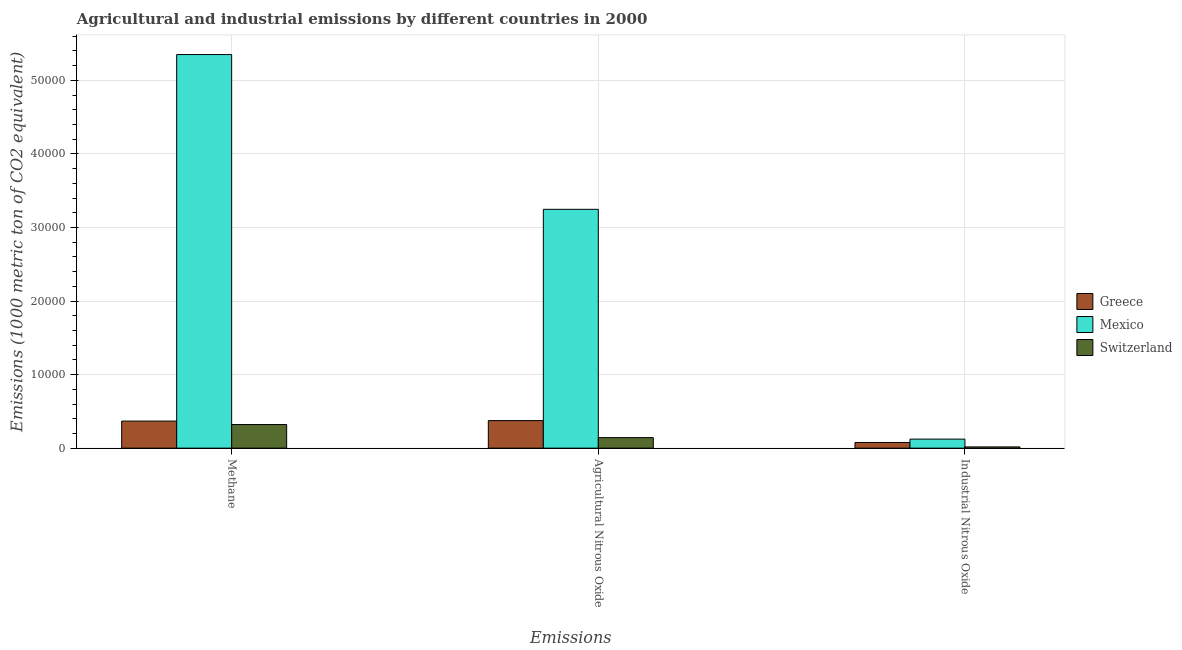How many different coloured bars are there?
Provide a short and direct response. 3. How many groups of bars are there?
Make the answer very short. 3. Are the number of bars on each tick of the X-axis equal?
Your answer should be very brief. Yes. How many bars are there on the 3rd tick from the left?
Give a very brief answer. 3. How many bars are there on the 1st tick from the right?
Offer a very short reply. 3. What is the label of the 1st group of bars from the left?
Ensure brevity in your answer.  Methane. What is the amount of agricultural nitrous oxide emissions in Mexico?
Offer a terse response. 3.25e+04. Across all countries, what is the maximum amount of methane emissions?
Provide a succinct answer. 5.35e+04. Across all countries, what is the minimum amount of agricultural nitrous oxide emissions?
Give a very brief answer. 1432.5. In which country was the amount of agricultural nitrous oxide emissions maximum?
Provide a succinct answer. Mexico. In which country was the amount of industrial nitrous oxide emissions minimum?
Provide a short and direct response. Switzerland. What is the total amount of agricultural nitrous oxide emissions in the graph?
Keep it short and to the point. 3.76e+04. What is the difference between the amount of agricultural nitrous oxide emissions in Mexico and that in Switzerland?
Your answer should be very brief. 3.10e+04. What is the difference between the amount of methane emissions in Mexico and the amount of industrial nitrous oxide emissions in Greece?
Provide a short and direct response. 5.27e+04. What is the average amount of agricultural nitrous oxide emissions per country?
Provide a short and direct response. 1.25e+04. What is the difference between the amount of industrial nitrous oxide emissions and amount of methane emissions in Greece?
Give a very brief answer. -2908.3. What is the ratio of the amount of industrial nitrous oxide emissions in Greece to that in Mexico?
Your answer should be very brief. 0.63. What is the difference between the highest and the second highest amount of methane emissions?
Offer a terse response. 4.98e+04. What is the difference between the highest and the lowest amount of agricultural nitrous oxide emissions?
Give a very brief answer. 3.10e+04. In how many countries, is the amount of agricultural nitrous oxide emissions greater than the average amount of agricultural nitrous oxide emissions taken over all countries?
Give a very brief answer. 1. What does the 3rd bar from the left in Agricultural Nitrous Oxide represents?
Provide a succinct answer. Switzerland. What does the 1st bar from the right in Agricultural Nitrous Oxide represents?
Your answer should be very brief. Switzerland. How many countries are there in the graph?
Your answer should be compact. 3. How are the legend labels stacked?
Your answer should be compact. Vertical. What is the title of the graph?
Provide a succinct answer. Agricultural and industrial emissions by different countries in 2000. What is the label or title of the X-axis?
Offer a very short reply. Emissions. What is the label or title of the Y-axis?
Give a very brief answer. Emissions (1000 metric ton of CO2 equivalent). What is the Emissions (1000 metric ton of CO2 equivalent) in Greece in Methane?
Provide a succinct answer. 3679.3. What is the Emissions (1000 metric ton of CO2 equivalent) of Mexico in Methane?
Provide a succinct answer. 5.35e+04. What is the Emissions (1000 metric ton of CO2 equivalent) of Switzerland in Methane?
Provide a succinct answer. 3210.7. What is the Emissions (1000 metric ton of CO2 equivalent) of Greece in Agricultural Nitrous Oxide?
Offer a very short reply. 3745.5. What is the Emissions (1000 metric ton of CO2 equivalent) of Mexico in Agricultural Nitrous Oxide?
Offer a terse response. 3.25e+04. What is the Emissions (1000 metric ton of CO2 equivalent) of Switzerland in Agricultural Nitrous Oxide?
Your response must be concise. 1432.5. What is the Emissions (1000 metric ton of CO2 equivalent) in Greece in Industrial Nitrous Oxide?
Provide a short and direct response. 771. What is the Emissions (1000 metric ton of CO2 equivalent) in Mexico in Industrial Nitrous Oxide?
Provide a short and direct response. 1227.6. What is the Emissions (1000 metric ton of CO2 equivalent) in Switzerland in Industrial Nitrous Oxide?
Give a very brief answer. 167.4. Across all Emissions, what is the maximum Emissions (1000 metric ton of CO2 equivalent) in Greece?
Provide a succinct answer. 3745.5. Across all Emissions, what is the maximum Emissions (1000 metric ton of CO2 equivalent) in Mexico?
Provide a succinct answer. 5.35e+04. Across all Emissions, what is the maximum Emissions (1000 metric ton of CO2 equivalent) in Switzerland?
Offer a terse response. 3210.7. Across all Emissions, what is the minimum Emissions (1000 metric ton of CO2 equivalent) in Greece?
Your answer should be very brief. 771. Across all Emissions, what is the minimum Emissions (1000 metric ton of CO2 equivalent) of Mexico?
Your answer should be very brief. 1227.6. Across all Emissions, what is the minimum Emissions (1000 metric ton of CO2 equivalent) in Switzerland?
Make the answer very short. 167.4. What is the total Emissions (1000 metric ton of CO2 equivalent) of Greece in the graph?
Provide a succinct answer. 8195.8. What is the total Emissions (1000 metric ton of CO2 equivalent) in Mexico in the graph?
Your answer should be very brief. 8.72e+04. What is the total Emissions (1000 metric ton of CO2 equivalent) in Switzerland in the graph?
Make the answer very short. 4810.6. What is the difference between the Emissions (1000 metric ton of CO2 equivalent) in Greece in Methane and that in Agricultural Nitrous Oxide?
Your answer should be compact. -66.2. What is the difference between the Emissions (1000 metric ton of CO2 equivalent) of Mexico in Methane and that in Agricultural Nitrous Oxide?
Provide a short and direct response. 2.10e+04. What is the difference between the Emissions (1000 metric ton of CO2 equivalent) of Switzerland in Methane and that in Agricultural Nitrous Oxide?
Provide a succinct answer. 1778.2. What is the difference between the Emissions (1000 metric ton of CO2 equivalent) of Greece in Methane and that in Industrial Nitrous Oxide?
Your answer should be compact. 2908.3. What is the difference between the Emissions (1000 metric ton of CO2 equivalent) in Mexico in Methane and that in Industrial Nitrous Oxide?
Provide a short and direct response. 5.23e+04. What is the difference between the Emissions (1000 metric ton of CO2 equivalent) of Switzerland in Methane and that in Industrial Nitrous Oxide?
Provide a short and direct response. 3043.3. What is the difference between the Emissions (1000 metric ton of CO2 equivalent) in Greece in Agricultural Nitrous Oxide and that in Industrial Nitrous Oxide?
Your answer should be compact. 2974.5. What is the difference between the Emissions (1000 metric ton of CO2 equivalent) of Mexico in Agricultural Nitrous Oxide and that in Industrial Nitrous Oxide?
Give a very brief answer. 3.12e+04. What is the difference between the Emissions (1000 metric ton of CO2 equivalent) of Switzerland in Agricultural Nitrous Oxide and that in Industrial Nitrous Oxide?
Ensure brevity in your answer.  1265.1. What is the difference between the Emissions (1000 metric ton of CO2 equivalent) in Greece in Methane and the Emissions (1000 metric ton of CO2 equivalent) in Mexico in Agricultural Nitrous Oxide?
Give a very brief answer. -2.88e+04. What is the difference between the Emissions (1000 metric ton of CO2 equivalent) in Greece in Methane and the Emissions (1000 metric ton of CO2 equivalent) in Switzerland in Agricultural Nitrous Oxide?
Your answer should be compact. 2246.8. What is the difference between the Emissions (1000 metric ton of CO2 equivalent) of Mexico in Methane and the Emissions (1000 metric ton of CO2 equivalent) of Switzerland in Agricultural Nitrous Oxide?
Make the answer very short. 5.21e+04. What is the difference between the Emissions (1000 metric ton of CO2 equivalent) of Greece in Methane and the Emissions (1000 metric ton of CO2 equivalent) of Mexico in Industrial Nitrous Oxide?
Provide a succinct answer. 2451.7. What is the difference between the Emissions (1000 metric ton of CO2 equivalent) of Greece in Methane and the Emissions (1000 metric ton of CO2 equivalent) of Switzerland in Industrial Nitrous Oxide?
Make the answer very short. 3511.9. What is the difference between the Emissions (1000 metric ton of CO2 equivalent) in Mexico in Methane and the Emissions (1000 metric ton of CO2 equivalent) in Switzerland in Industrial Nitrous Oxide?
Your response must be concise. 5.33e+04. What is the difference between the Emissions (1000 metric ton of CO2 equivalent) in Greece in Agricultural Nitrous Oxide and the Emissions (1000 metric ton of CO2 equivalent) in Mexico in Industrial Nitrous Oxide?
Offer a very short reply. 2517.9. What is the difference between the Emissions (1000 metric ton of CO2 equivalent) of Greece in Agricultural Nitrous Oxide and the Emissions (1000 metric ton of CO2 equivalent) of Switzerland in Industrial Nitrous Oxide?
Provide a succinct answer. 3578.1. What is the difference between the Emissions (1000 metric ton of CO2 equivalent) in Mexico in Agricultural Nitrous Oxide and the Emissions (1000 metric ton of CO2 equivalent) in Switzerland in Industrial Nitrous Oxide?
Make the answer very short. 3.23e+04. What is the average Emissions (1000 metric ton of CO2 equivalent) in Greece per Emissions?
Your answer should be compact. 2731.93. What is the average Emissions (1000 metric ton of CO2 equivalent) of Mexico per Emissions?
Ensure brevity in your answer.  2.91e+04. What is the average Emissions (1000 metric ton of CO2 equivalent) of Switzerland per Emissions?
Your answer should be compact. 1603.53. What is the difference between the Emissions (1000 metric ton of CO2 equivalent) in Greece and Emissions (1000 metric ton of CO2 equivalent) in Mexico in Methane?
Your answer should be compact. -4.98e+04. What is the difference between the Emissions (1000 metric ton of CO2 equivalent) in Greece and Emissions (1000 metric ton of CO2 equivalent) in Switzerland in Methane?
Your answer should be very brief. 468.6. What is the difference between the Emissions (1000 metric ton of CO2 equivalent) of Mexico and Emissions (1000 metric ton of CO2 equivalent) of Switzerland in Methane?
Give a very brief answer. 5.03e+04. What is the difference between the Emissions (1000 metric ton of CO2 equivalent) of Greece and Emissions (1000 metric ton of CO2 equivalent) of Mexico in Agricultural Nitrous Oxide?
Provide a short and direct response. -2.87e+04. What is the difference between the Emissions (1000 metric ton of CO2 equivalent) in Greece and Emissions (1000 metric ton of CO2 equivalent) in Switzerland in Agricultural Nitrous Oxide?
Your answer should be very brief. 2313. What is the difference between the Emissions (1000 metric ton of CO2 equivalent) of Mexico and Emissions (1000 metric ton of CO2 equivalent) of Switzerland in Agricultural Nitrous Oxide?
Your answer should be compact. 3.10e+04. What is the difference between the Emissions (1000 metric ton of CO2 equivalent) of Greece and Emissions (1000 metric ton of CO2 equivalent) of Mexico in Industrial Nitrous Oxide?
Give a very brief answer. -456.6. What is the difference between the Emissions (1000 metric ton of CO2 equivalent) of Greece and Emissions (1000 metric ton of CO2 equivalent) of Switzerland in Industrial Nitrous Oxide?
Ensure brevity in your answer.  603.6. What is the difference between the Emissions (1000 metric ton of CO2 equivalent) in Mexico and Emissions (1000 metric ton of CO2 equivalent) in Switzerland in Industrial Nitrous Oxide?
Your answer should be compact. 1060.2. What is the ratio of the Emissions (1000 metric ton of CO2 equivalent) in Greece in Methane to that in Agricultural Nitrous Oxide?
Keep it short and to the point. 0.98. What is the ratio of the Emissions (1000 metric ton of CO2 equivalent) of Mexico in Methane to that in Agricultural Nitrous Oxide?
Make the answer very short. 1.65. What is the ratio of the Emissions (1000 metric ton of CO2 equivalent) of Switzerland in Methane to that in Agricultural Nitrous Oxide?
Offer a very short reply. 2.24. What is the ratio of the Emissions (1000 metric ton of CO2 equivalent) of Greece in Methane to that in Industrial Nitrous Oxide?
Keep it short and to the point. 4.77. What is the ratio of the Emissions (1000 metric ton of CO2 equivalent) in Mexico in Methane to that in Industrial Nitrous Oxide?
Provide a short and direct response. 43.59. What is the ratio of the Emissions (1000 metric ton of CO2 equivalent) in Switzerland in Methane to that in Industrial Nitrous Oxide?
Give a very brief answer. 19.18. What is the ratio of the Emissions (1000 metric ton of CO2 equivalent) of Greece in Agricultural Nitrous Oxide to that in Industrial Nitrous Oxide?
Give a very brief answer. 4.86. What is the ratio of the Emissions (1000 metric ton of CO2 equivalent) of Mexico in Agricultural Nitrous Oxide to that in Industrial Nitrous Oxide?
Make the answer very short. 26.45. What is the ratio of the Emissions (1000 metric ton of CO2 equivalent) of Switzerland in Agricultural Nitrous Oxide to that in Industrial Nitrous Oxide?
Offer a very short reply. 8.56. What is the difference between the highest and the second highest Emissions (1000 metric ton of CO2 equivalent) in Greece?
Provide a short and direct response. 66.2. What is the difference between the highest and the second highest Emissions (1000 metric ton of CO2 equivalent) of Mexico?
Your answer should be very brief. 2.10e+04. What is the difference between the highest and the second highest Emissions (1000 metric ton of CO2 equivalent) of Switzerland?
Provide a short and direct response. 1778.2. What is the difference between the highest and the lowest Emissions (1000 metric ton of CO2 equivalent) of Greece?
Offer a very short reply. 2974.5. What is the difference between the highest and the lowest Emissions (1000 metric ton of CO2 equivalent) of Mexico?
Ensure brevity in your answer.  5.23e+04. What is the difference between the highest and the lowest Emissions (1000 metric ton of CO2 equivalent) of Switzerland?
Provide a short and direct response. 3043.3. 